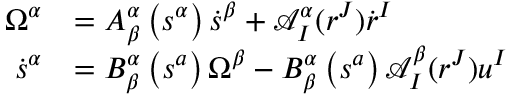<formula> <loc_0><loc_0><loc_500><loc_500>\begin{array} { r l } { \Omega ^ { \alpha } } & { = A _ { \beta } ^ { \alpha } \left ( s ^ { \alpha } \right ) \dot { s } ^ { \beta } + \mathcal { A } _ { I } ^ { \alpha } ( r ^ { J } ) \dot { r } ^ { I } } \\ { \dot { s } ^ { \alpha } } & { = B _ { \beta } ^ { \alpha } \left ( s ^ { a } \right ) \Omega ^ { \beta } - B _ { \beta } ^ { \alpha } \left ( s ^ { a } \right ) \mathcal { A } _ { I } ^ { \beta } ( r ^ { J } ) u ^ { I } } \end{array}</formula> 